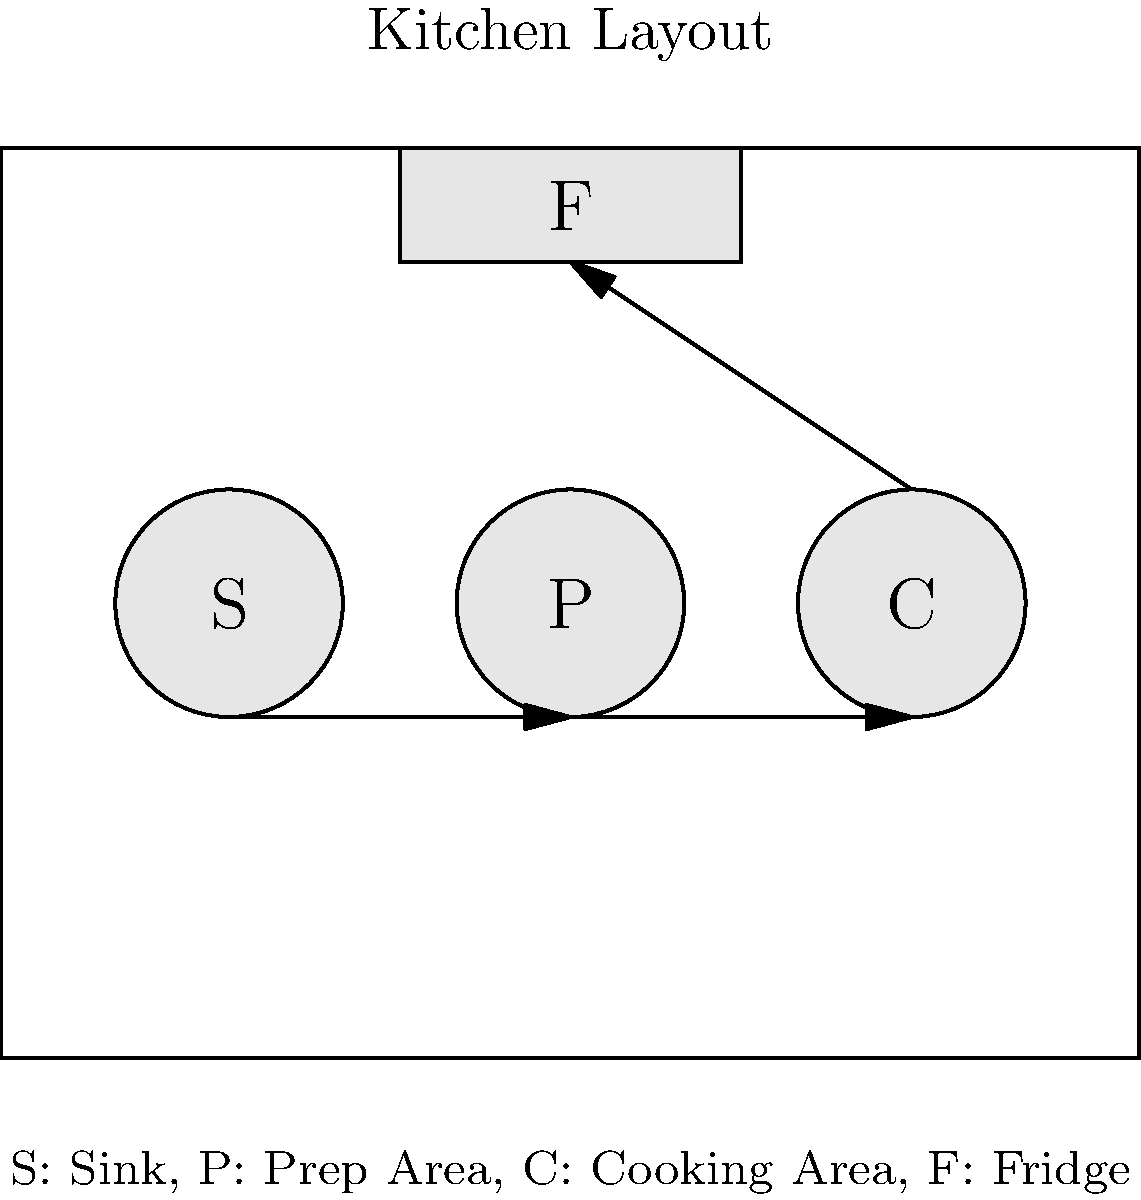In the kitchen layout shown, which arrangement of the sink (S), prep area (P), and cooking area (C) creates the most efficient workflow for meal preparation? Explain why this arrangement is optimal for a chef focused on meal planning and batch cooking. To determine the most efficient workflow for meal preparation, especially for a chef focused on meal planning and batch cooking, we need to consider the following steps:

1. Analyze the given layout:
   - The layout shows a linear arrangement of Sink (S), Prep Area (P), and Cooking Area (C).
   - The refrigerator (F) is positioned above these three main work areas.

2. Consider the typical workflow in meal preparation:
   a) Retrieve ingredients from the refrigerator
   b) Wash and clean ingredients at the sink
   c) Prepare and chop ingredients in the prep area
   d) Cook the prepared ingredients in the cooking area

3. Evaluate the current arrangement:
   - The flow from S → P → C allows for a natural progression of tasks.
   - This arrangement minimizes unnecessary movement and backtracking.

4. Analyze the benefits for meal planning and batch cooking:
   - Ingredients can be efficiently moved from the fridge to the sink for cleaning.
   - The prep area is centrally located, allowing easy access to both cleaned ingredients and the cooking area.
   - Large batches of ingredients can be prepared and easily transferred to the cooking area.

5. Consider the concept of the "kitchen work triangle":
   - The current layout forms an efficient triangle between the fridge, sink, and cooking area.
   - This arrangement minimizes walking distance and optimizes workflow.

6. Conclusion:
   The given arrangement (S → P → C) is optimal for a chef focused on meal planning and batch cooking because it allows for a smooth, logical flow of tasks from ingredient retrieval to final cooking, minimizing wasted movement and maximizing efficiency in preparing large batches of meals.
Answer: S → P → C (Sink → Prep Area → Cooking Area) 